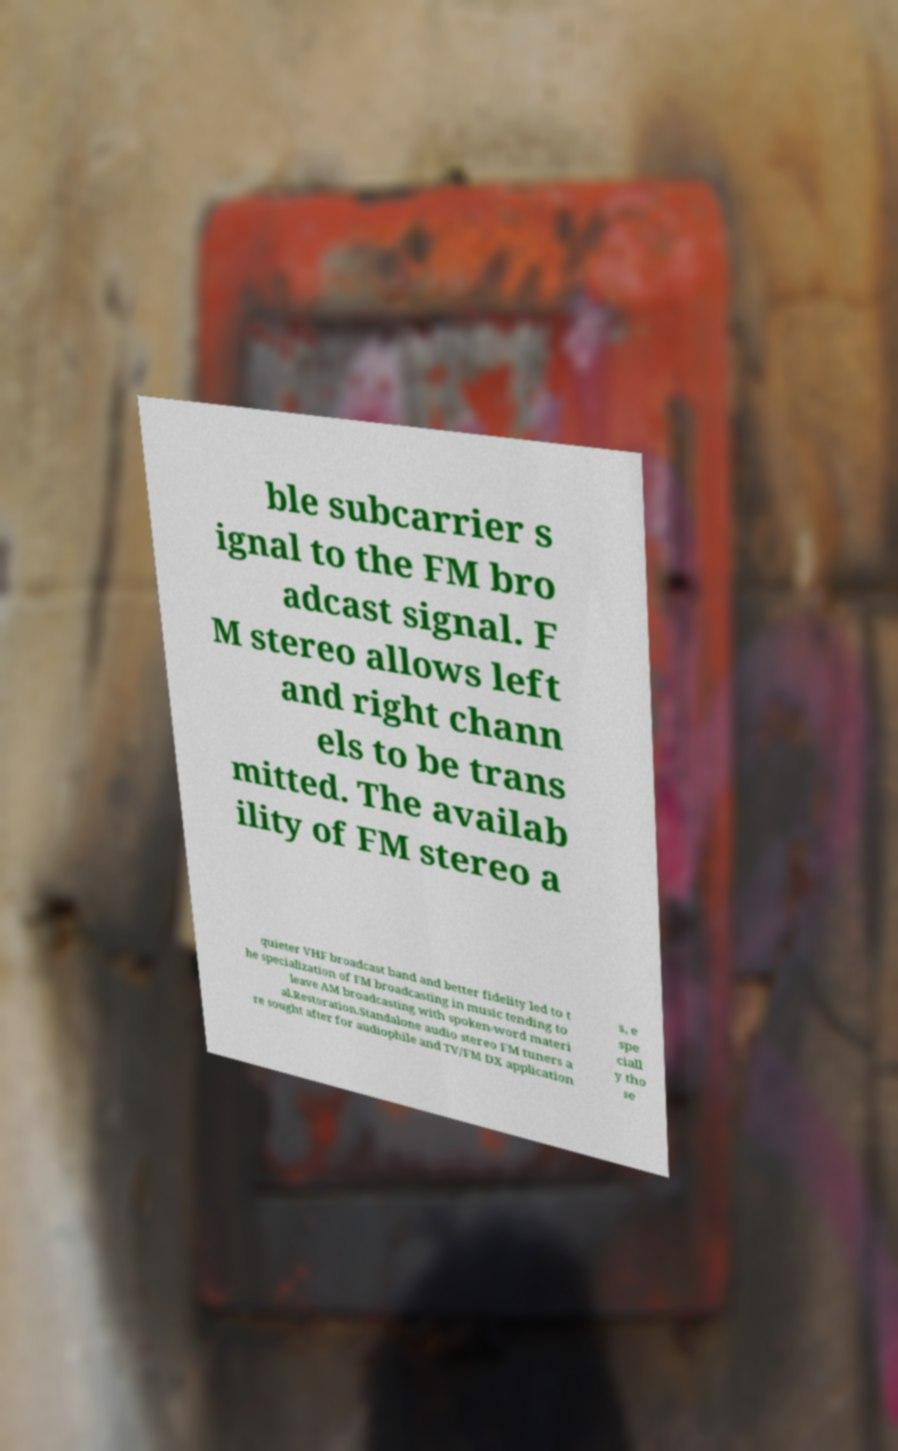Please read and relay the text visible in this image. What does it say? ble subcarrier s ignal to the FM bro adcast signal. F M stereo allows left and right chann els to be trans mitted. The availab ility of FM stereo a quieter VHF broadcast band and better fidelity led to t he specialization of FM broadcasting in music tending to leave AM broadcasting with spoken-word materi al.Restoration.Standalone audio stereo FM tuners a re sought after for audiophile and TV/FM DX application s, e spe ciall y tho se 